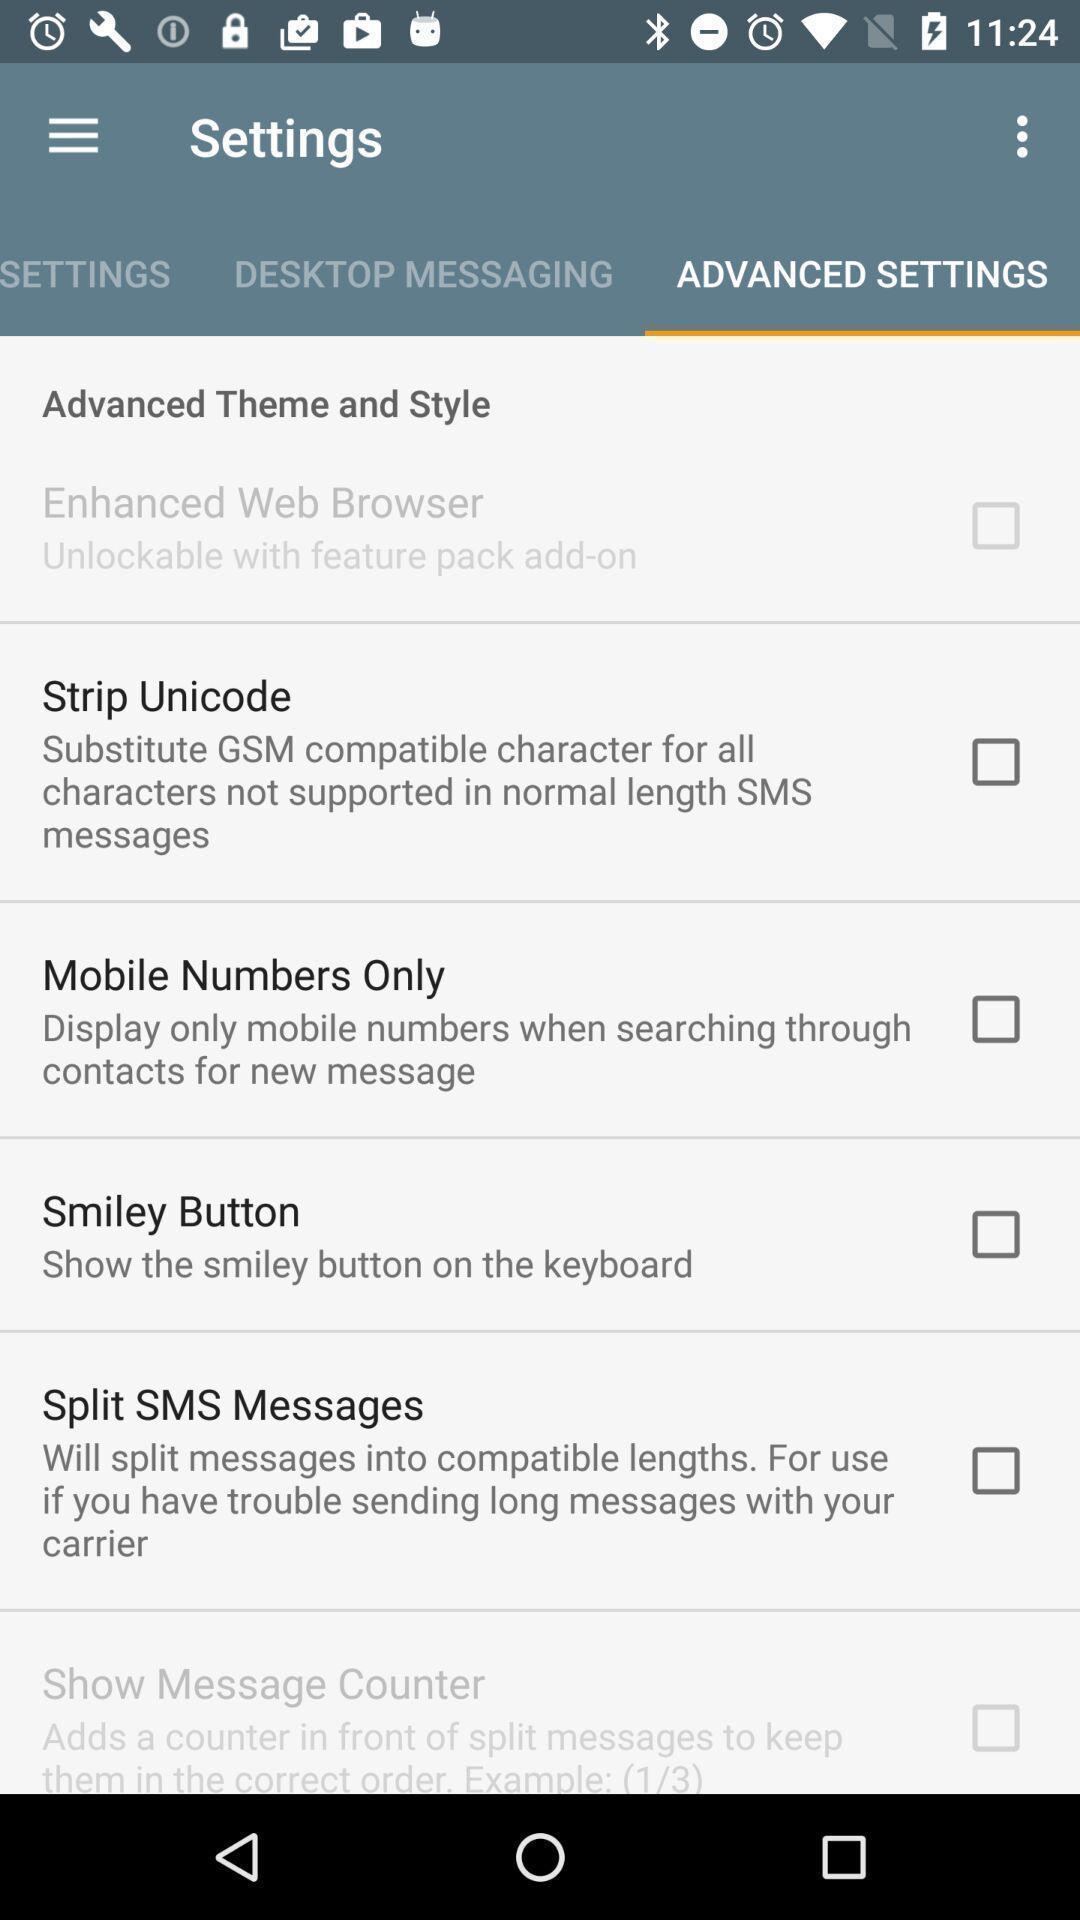Give me a narrative description of this picture. Screen shows several settings options. 